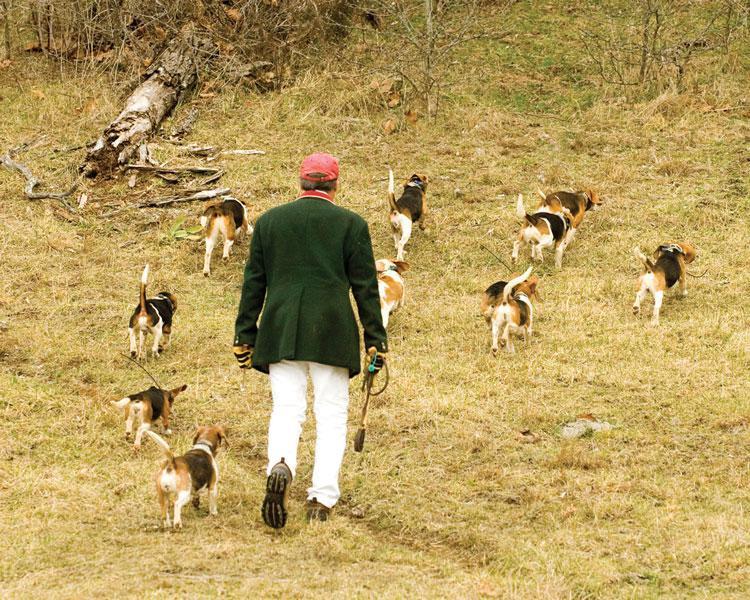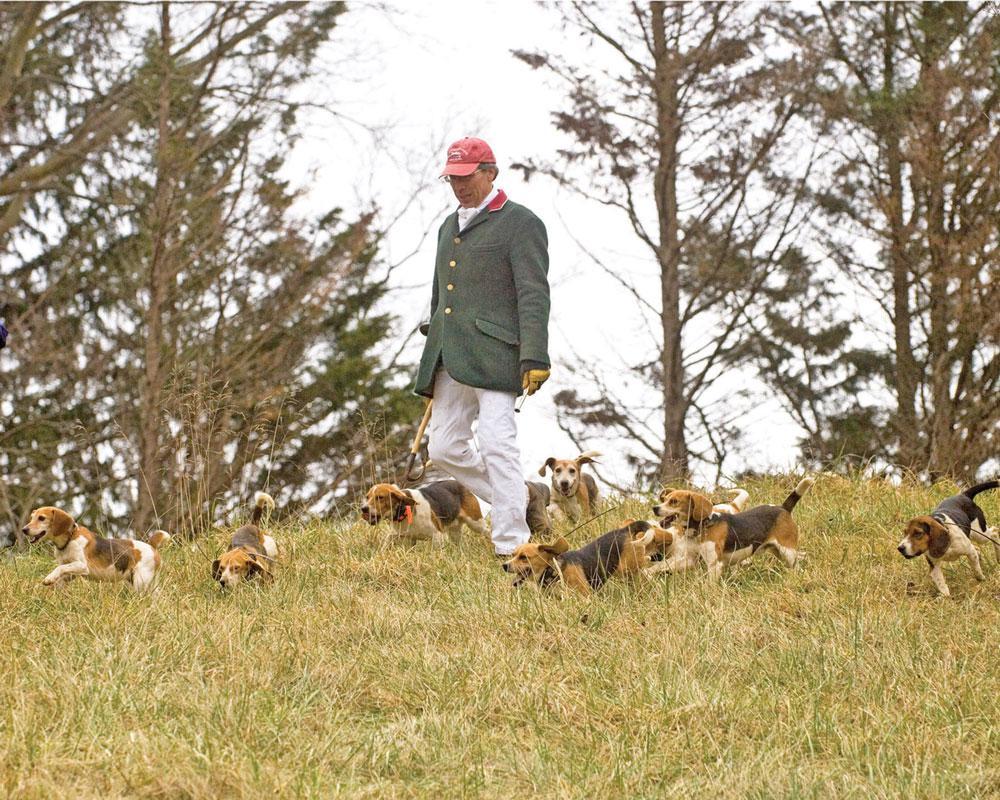The first image is the image on the left, the second image is the image on the right. For the images shown, is this caption "There is no more than two people in both images." true? Answer yes or no. Yes. 